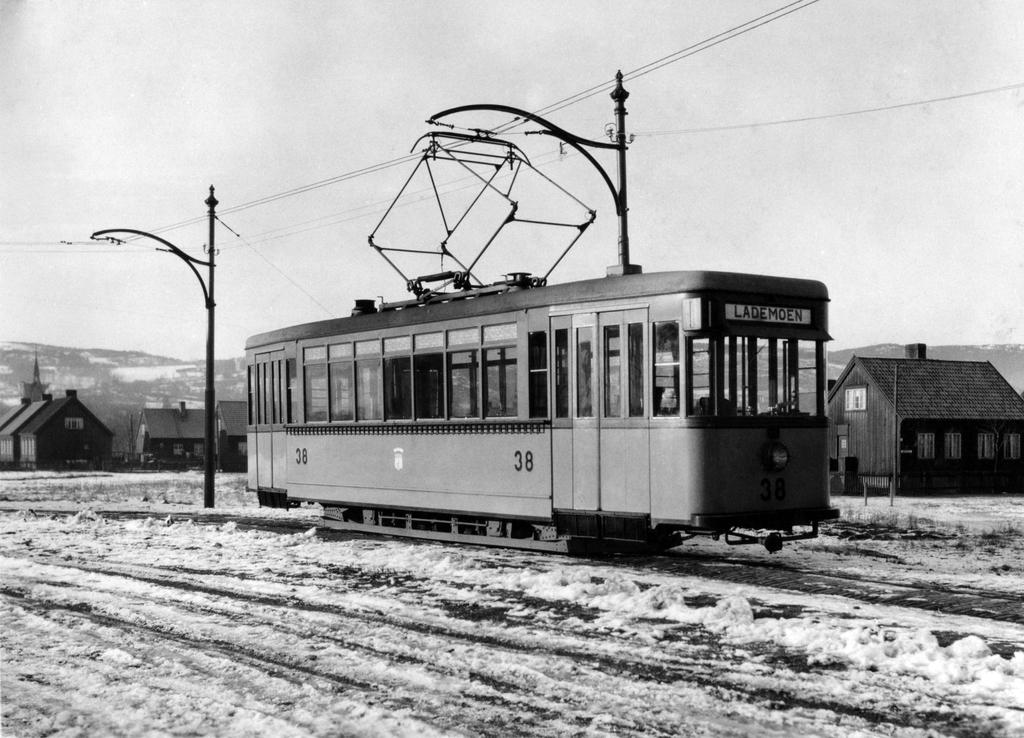What is the color scheme of the image? The image is black and white. What can be seen in the foreground of the image? There is a vehicle in the image. What objects are located behind the vehicle? There are two poles behind the vehicle. What type of structures can be seen in the background of the image? There are two houses in the background of the image. How many pies are being served in harmony in the image? There are no pies or any indication of harmony present in the image. 